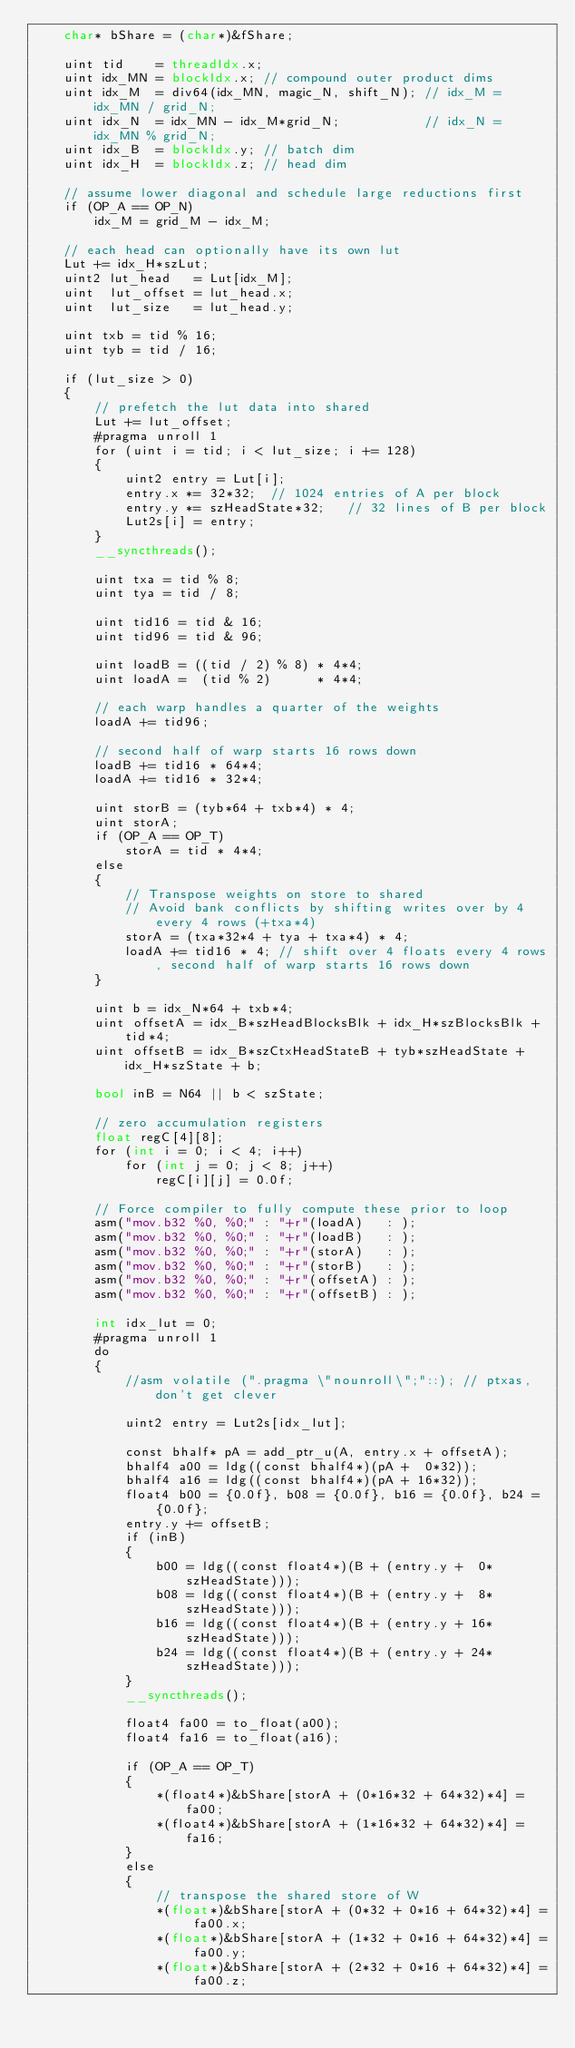<code> <loc_0><loc_0><loc_500><loc_500><_Cuda_>    char* bShare = (char*)&fShare;

    uint tid    = threadIdx.x;
    uint idx_MN = blockIdx.x; // compound outer product dims
    uint idx_M  = div64(idx_MN, magic_N, shift_N); // idx_M = idx_MN / grid_N;
    uint idx_N  = idx_MN - idx_M*grid_N;           // idx_N = idx_MN % grid_N;
    uint idx_B  = blockIdx.y; // batch dim
    uint idx_H  = blockIdx.z; // head dim

    // assume lower diagonal and schedule large reductions first
    if (OP_A == OP_N)
        idx_M = grid_M - idx_M;

    // each head can optionally have its own lut
    Lut += idx_H*szLut;
    uint2 lut_head   = Lut[idx_M];
    uint  lut_offset = lut_head.x;
    uint  lut_size   = lut_head.y;

    uint txb = tid % 16;
    uint tyb = tid / 16;

    if (lut_size > 0)
    {
        // prefetch the lut data into shared
        Lut += lut_offset;
        #pragma unroll 1
        for (uint i = tid; i < lut_size; i += 128)
        {
            uint2 entry = Lut[i];
            entry.x *= 32*32;  // 1024 entries of A per block
            entry.y *= szHeadState*32;   // 32 lines of B per block
            Lut2s[i] = entry;
        }
        __syncthreads();

        uint txa = tid % 8;
        uint tya = tid / 8;

        uint tid16 = tid & 16;
        uint tid96 = tid & 96;

        uint loadB = ((tid / 2) % 8) * 4*4;
        uint loadA =  (tid % 2)      * 4*4;

        // each warp handles a quarter of the weights
        loadA += tid96;

        // second half of warp starts 16 rows down
        loadB += tid16 * 64*4;
        loadA += tid16 * 32*4;

        uint storB = (tyb*64 + txb*4) * 4;
        uint storA;
        if (OP_A == OP_T)
            storA = tid * 4*4;
        else
        {
            // Transpose weights on store to shared
            // Avoid bank conflicts by shifting writes over by 4 every 4 rows (+txa*4)
            storA = (txa*32*4 + tya + txa*4) * 4;
            loadA += tid16 * 4; // shift over 4 floats every 4 rows, second half of warp starts 16 rows down
        }

        uint b = idx_N*64 + txb*4;
        uint offsetA = idx_B*szHeadBlocksBlk + idx_H*szBlocksBlk + tid*4;
        uint offsetB = idx_B*szCtxHeadStateB + tyb*szHeadState + idx_H*szState + b;

        bool inB = N64 || b < szState;

        // zero accumulation registers
        float regC[4][8];
        for (int i = 0; i < 4; i++)
            for (int j = 0; j < 8; j++)
                regC[i][j] = 0.0f;

        // Force compiler to fully compute these prior to loop
        asm("mov.b32 %0, %0;" : "+r"(loadA)   : );
        asm("mov.b32 %0, %0;" : "+r"(loadB)   : );
        asm("mov.b32 %0, %0;" : "+r"(storA)   : );
        asm("mov.b32 %0, %0;" : "+r"(storB)   : );
        asm("mov.b32 %0, %0;" : "+r"(offsetA) : );
        asm("mov.b32 %0, %0;" : "+r"(offsetB) : );

        int idx_lut = 0;
        #pragma unroll 1
        do
        {
            //asm volatile (".pragma \"nounroll\";"::); // ptxas, don't get clever

            uint2 entry = Lut2s[idx_lut];

            const bhalf* pA = add_ptr_u(A, entry.x + offsetA);
            bhalf4 a00 = ldg((const bhalf4*)(pA +  0*32));
            bhalf4 a16 = ldg((const bhalf4*)(pA + 16*32));
            float4 b00 = {0.0f}, b08 = {0.0f}, b16 = {0.0f}, b24 = {0.0f};
            entry.y += offsetB;
            if (inB)
            {
                b00 = ldg((const float4*)(B + (entry.y +  0*szHeadState)));
                b08 = ldg((const float4*)(B + (entry.y +  8*szHeadState)));
                b16 = ldg((const float4*)(B + (entry.y + 16*szHeadState)));
                b24 = ldg((const float4*)(B + (entry.y + 24*szHeadState)));
            }
            __syncthreads();

            float4 fa00 = to_float(a00);
            float4 fa16 = to_float(a16);

            if (OP_A == OP_T)
            {
                *(float4*)&bShare[storA + (0*16*32 + 64*32)*4] = fa00;
                *(float4*)&bShare[storA + (1*16*32 + 64*32)*4] = fa16;
            }
            else
            {
                // transpose the shared store of W
                *(float*)&bShare[storA + (0*32 + 0*16 + 64*32)*4] = fa00.x;
                *(float*)&bShare[storA + (1*32 + 0*16 + 64*32)*4] = fa00.y;
                *(float*)&bShare[storA + (2*32 + 0*16 + 64*32)*4] = fa00.z;</code> 